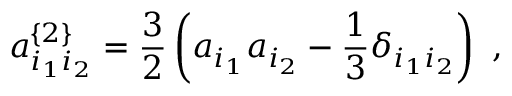Convert formula to latex. <formula><loc_0><loc_0><loc_500><loc_500>a _ { i _ { 1 } i _ { 2 } } ^ { \{ 2 \} } = \frac { 3 } { 2 } \left ( a _ { i _ { 1 } } a _ { i _ { 2 } } - \frac { 1 } { 3 } \delta _ { i _ { 1 } i _ { 2 } } \right ) \ ,</formula> 